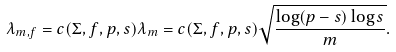<formula> <loc_0><loc_0><loc_500><loc_500>\lambda _ { m , f } = c ( \Sigma , f , p , s ) \lambda _ { m } = c ( \Sigma , f , p , s ) \sqrt { \frac { \log ( p - s ) \log s } { m } } .</formula> 